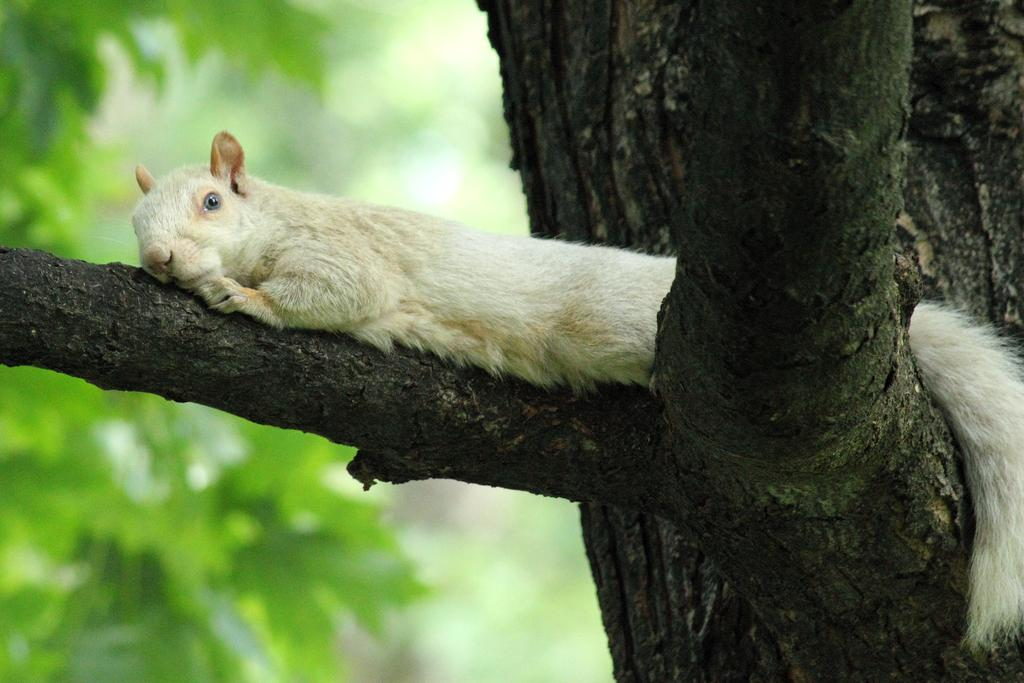What type of animal can be seen in the image? There is an animal in the image, but we cannot determine the specific type from the provided facts. Where is the animal located in the image? The animal is lying on the branch of a tree. What is the weight of the animal's father in the image? There is no information about the animal's father or weight in the image. 